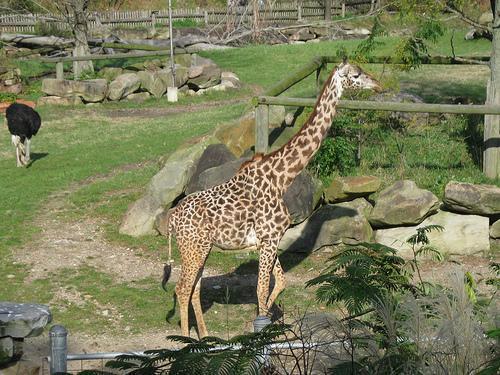How many giraffes are there?
Give a very brief answer. 1. 